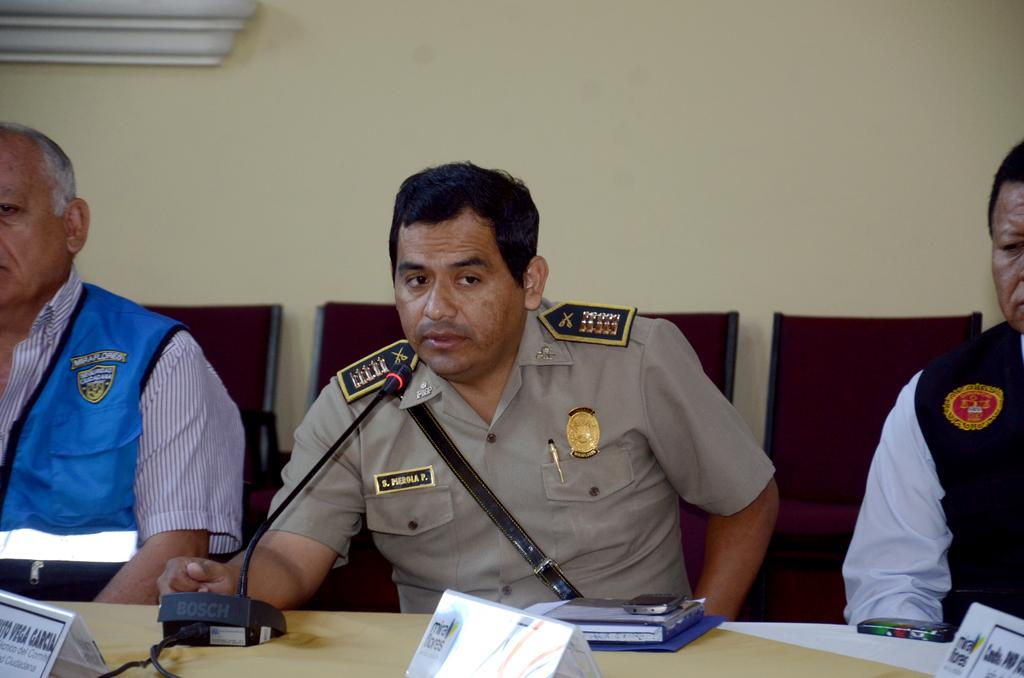What are the people in the image doing? The people in the image are sitting on chairs. What is in front of the chairs? There is a table in front of the chairs. What items can be seen on the table? Name boards, books, a mobile phone, and a microphone are visible on the table. What type of spark can be seen coming from the microphone in the image? There is no spark coming from the microphone in the image; it is a stationary object on the table. 